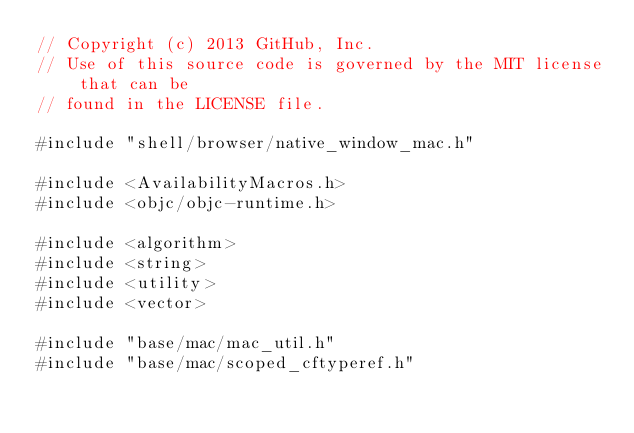Convert code to text. <code><loc_0><loc_0><loc_500><loc_500><_ObjectiveC_>// Copyright (c) 2013 GitHub, Inc.
// Use of this source code is governed by the MIT license that can be
// found in the LICENSE file.

#include "shell/browser/native_window_mac.h"

#include <AvailabilityMacros.h>
#include <objc/objc-runtime.h>

#include <algorithm>
#include <string>
#include <utility>
#include <vector>

#include "base/mac/mac_util.h"
#include "base/mac/scoped_cftyperef.h"</code> 